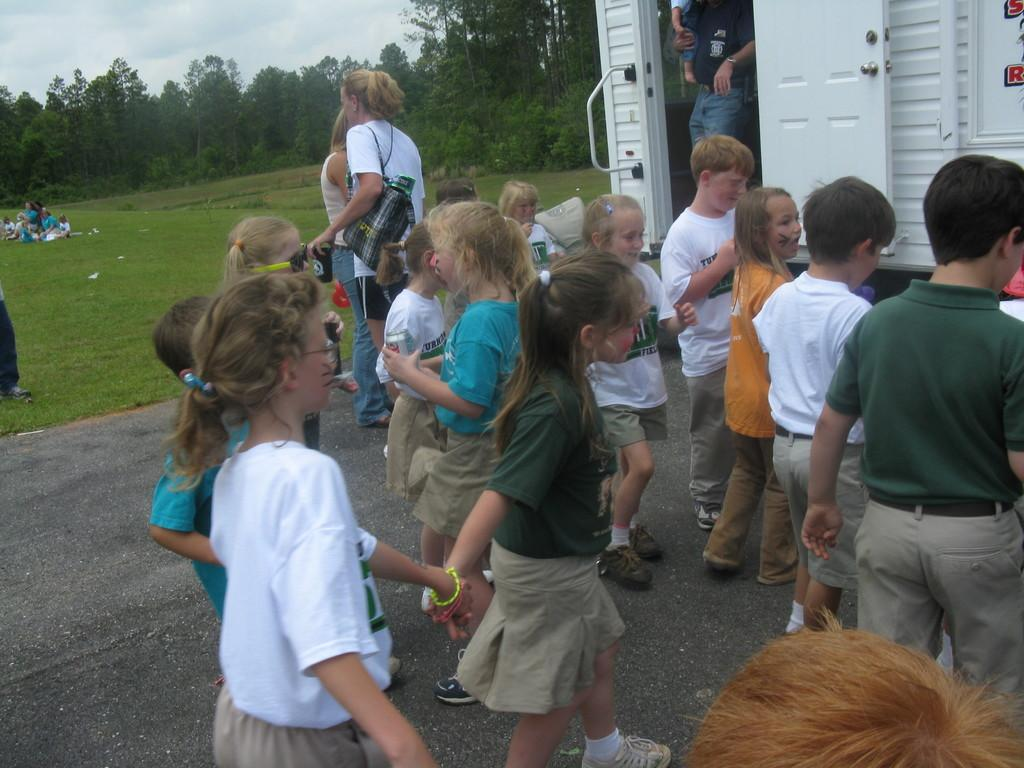Who or what can be seen in the image? There are people in the image. What type of object is also present in the image? There is a vehicle in the image. What type of natural environment is visible in the image? Grass, trees, and the sky are visible in the image. What type of music can be heard coming from the vehicle in the image? There is no indication of any music or sound in the image, so it cannot be determined from the image. 